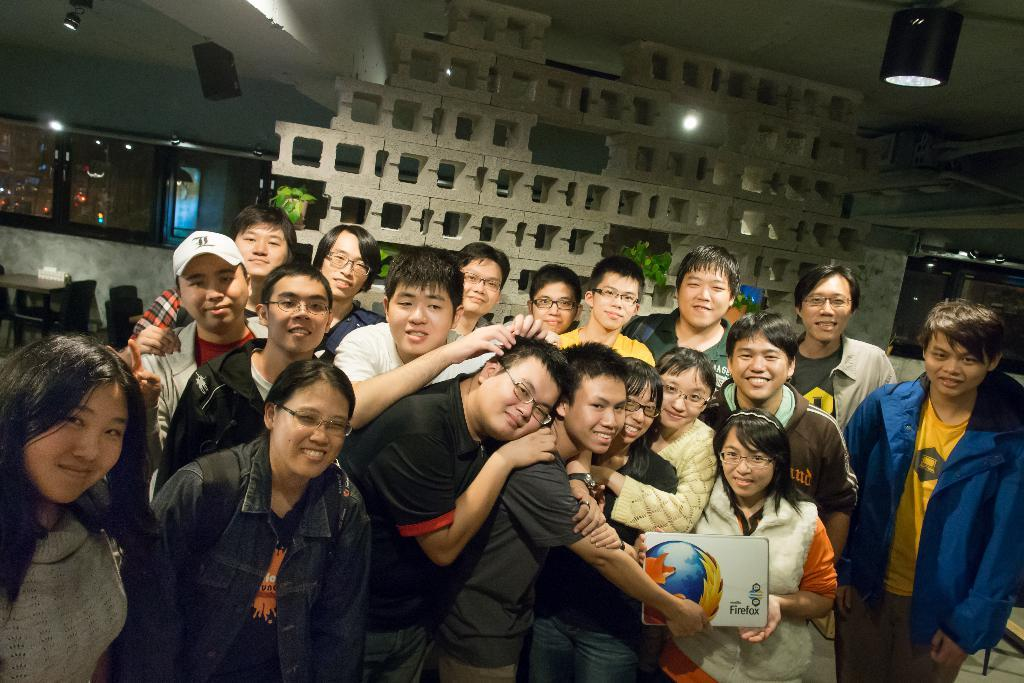Who or what can be seen in the image? There are people in the image. What are some of the people doing in the image? Some people are holding something. What can be seen illuminating the scene in the image? There are lights visible in the image. What type of furniture is present in the image? There is a table and chairs in the image. What type of engine can be seen powering the coat in the image? There is no engine or coat present in the image. How does the heart affect the people in the image? The image does not show any hearts or their effects on the people. 